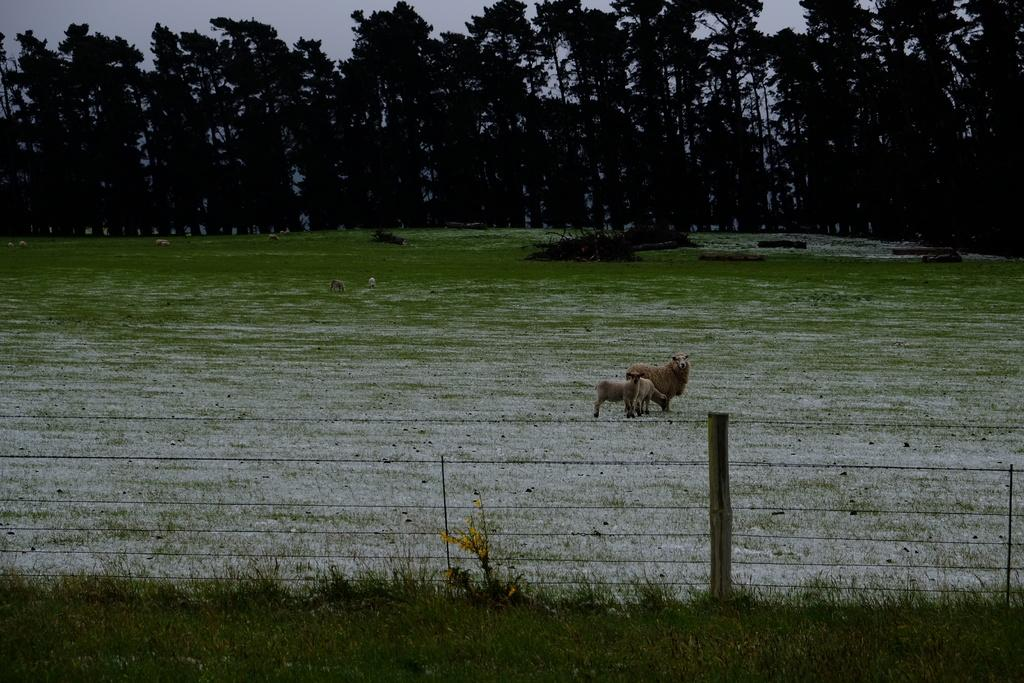What animals can be seen on the ground in the image? There is a flock of sheep on the ground in the image. What type of vegetation is visible in the background of the image? There are trees in the background of the image. What can be seen in the foreground of the image? There is a boundary in the foreground of the image. What letters are spelled out by the sheep in the image? There are no letters spelled out by the sheep in the image; they are simply a flock of sheep on the ground. 